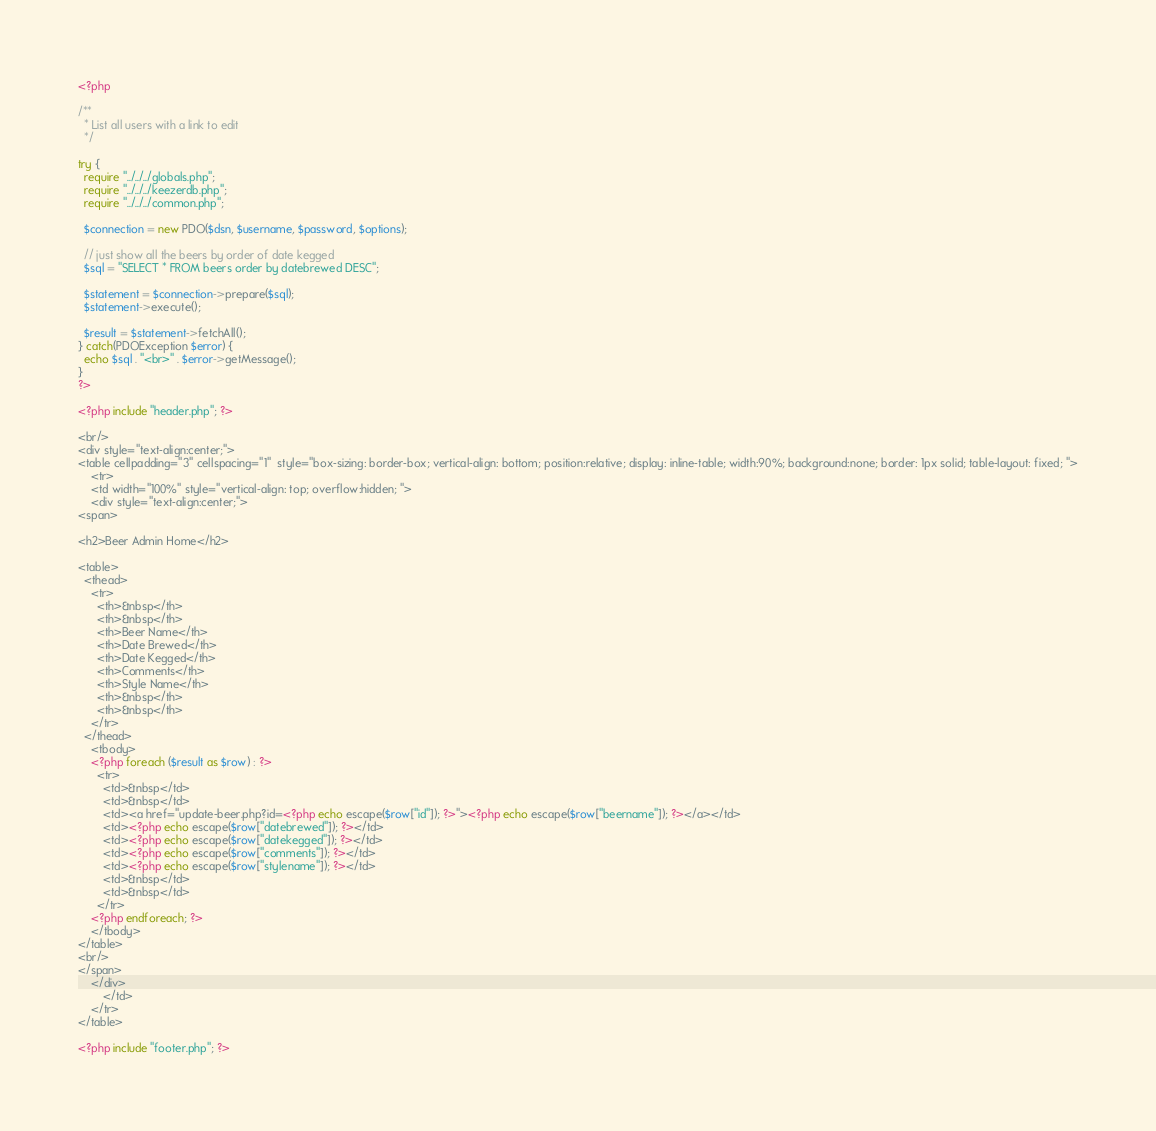Convert code to text. <code><loc_0><loc_0><loc_500><loc_500><_PHP_><?php

/**
  * List all users with a link to edit
  */

try {
  require "../../../globals.php";
  require "../../../keezerdb.php";
  require "../../../common.php";

  $connection = new PDO($dsn, $username, $password, $options);

  // just show all the beers by order of date kegged
  $sql = "SELECT * FROM beers order by datebrewed DESC";

  $statement = $connection->prepare($sql);
  $statement->execute();

  $result = $statement->fetchAll();
} catch(PDOException $error) {
  echo $sql . "<br>" . $error->getMessage();
}
?>

<?php include "header.php"; ?>

<br/>
<div style="text-align:center;">
<table cellpadding="3" cellspacing="1"  style="box-sizing: border-box; vertical-align: bottom; position:relative; display: inline-table; width:90%; background:none; border: 1px solid; table-layout: fixed; ">
	<tr>
	<td width="100%" style="vertical-align: top; overflow:hidden; ">
    <div style="text-align:center;">
<span>

<h2>Beer Admin Home</h2>

<table>
  <thead>
    <tr>
      <th>&nbsp</th>
      <th>&nbsp</th>
      <th>Beer Name</th>
      <th>Date Brewed</th>
      <th>Date Kegged</th>
      <th>Comments</th>
      <th>Style Name</th>
      <th>&nbsp</th>
      <th>&nbsp</th>
    </tr>
  </thead>
    <tbody>
    <?php foreach ($result as $row) : ?>
      <tr>
        <td>&nbsp</td>
        <td>&nbsp</td>
        <td><a href="update-beer.php?id=<?php echo escape($row["id"]); ?>"><?php echo escape($row["beername"]); ?></a></td>
        <td><?php echo escape($row["datebrewed"]); ?></td>
        <td><?php echo escape($row["datekegged"]); ?></td>
        <td><?php echo escape($row["comments"]); ?></td>
        <td><?php echo escape($row["stylename"]); ?></td>
        <td>&nbsp</td>
        <td>&nbsp</td>
      </tr>
    <?php endforeach; ?>
    </tbody>
</table>
<br/>
</span>
    </div>
		</td>
	</tr>
</table>

<?php include "footer.php"; ?>
</code> 